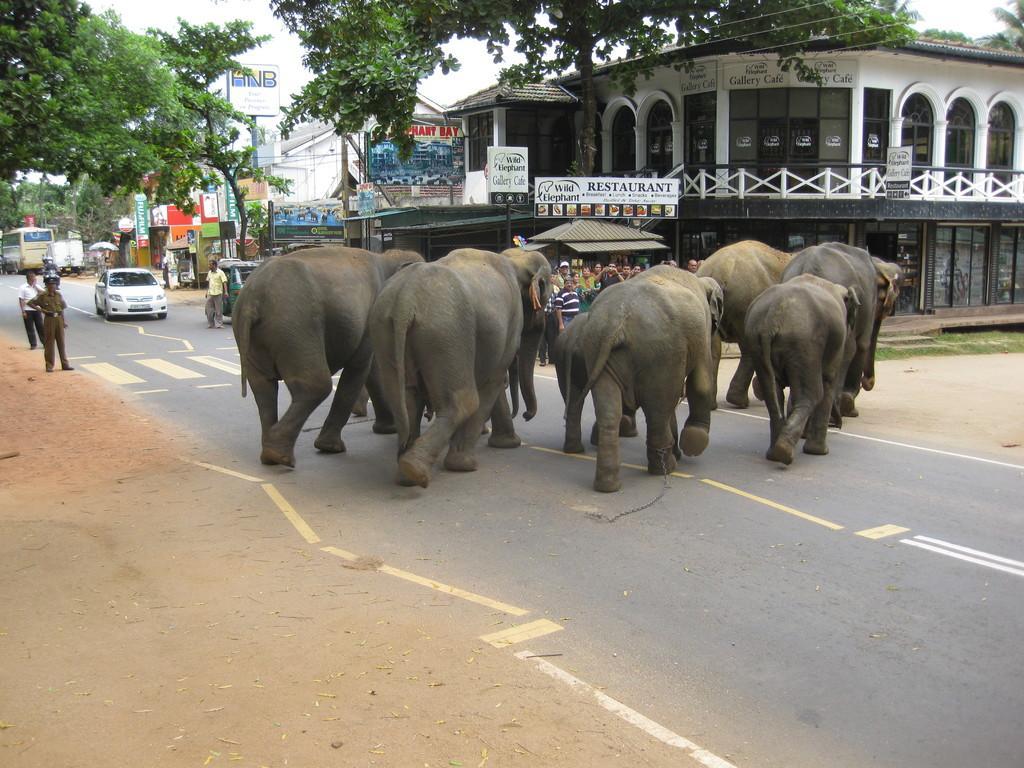Could you give a brief overview of what you see in this image? In this picture there is a group of elephant crossing the road. Behind there is a white color building with arch window and door. Beside some shop and naming board. On the left behind we can see a police man is standing and watching. In the background there is a white color car and a bus on the road. 